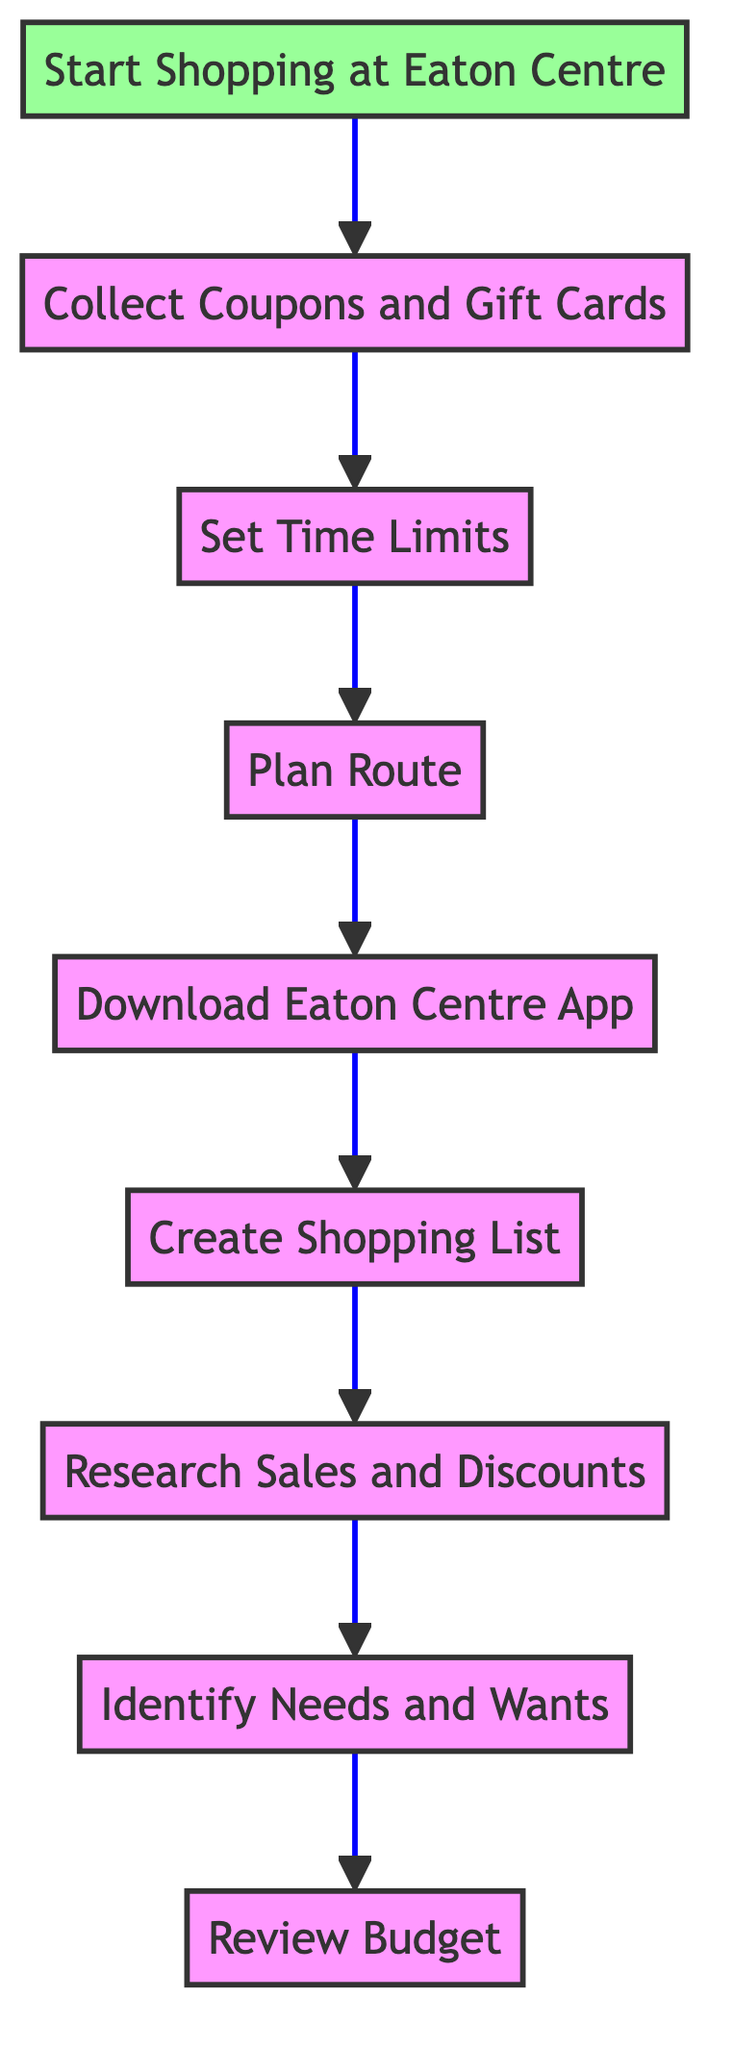What is the first step in the diagram? The first step is "Review Budget," which has no dependencies and initiates the process flow.
Answer: Review Budget How many total steps are included in the diagram? The diagram contains a total of 9 steps, including the final action of starting shopping.
Answer: 9 Which step comes immediately after "Create Shopping List"? "Download Eaton Centre App" is the step that comes immediately after "Create Shopping List" in the flow.
Answer: Download Eaton Centre App What is the last step in the process? The last step is "Start Shopping at Eaton Centre," which follows the preceding steps as the final action to be taken.
Answer: Start Shopping at Eaton Centre Which step requires the completion of "Set Time Limits"? "Collect Coupons and Gift Cards" requires the completion of "Set Time Limits" before proceeding.
Answer: Collect Coupons and Gift Cards What is the relationship between "Research Sales and Discounts" and "Identify Needs and Wants"? "Research Sales and Discounts" depends on "Identify Needs and Wants," meaning it cannot be started until the previous step is completed.
Answer: Depends Which step is dependent on both "Plan Route" and "Download Eaton Centre App"? "Set Time Limits" is dependent on completing "Plan Route," which in turn depends on "Download Eaton Centre App."
Answer: Set Time Limits What comes before "Start Shopping at Eaton Centre"? "Collect Coupons and Gift Cards" is the step that must be completed before "Start Shopping at Eaton Centre."
Answer: Collect Coupons and Gift Cards How does the flow of the diagram progress? The flow progresses from bottom to top, meaning actions are taken sequentially from "Start Shopping at Eaton Centre" up to "Review Budget."
Answer: Bottom to top 